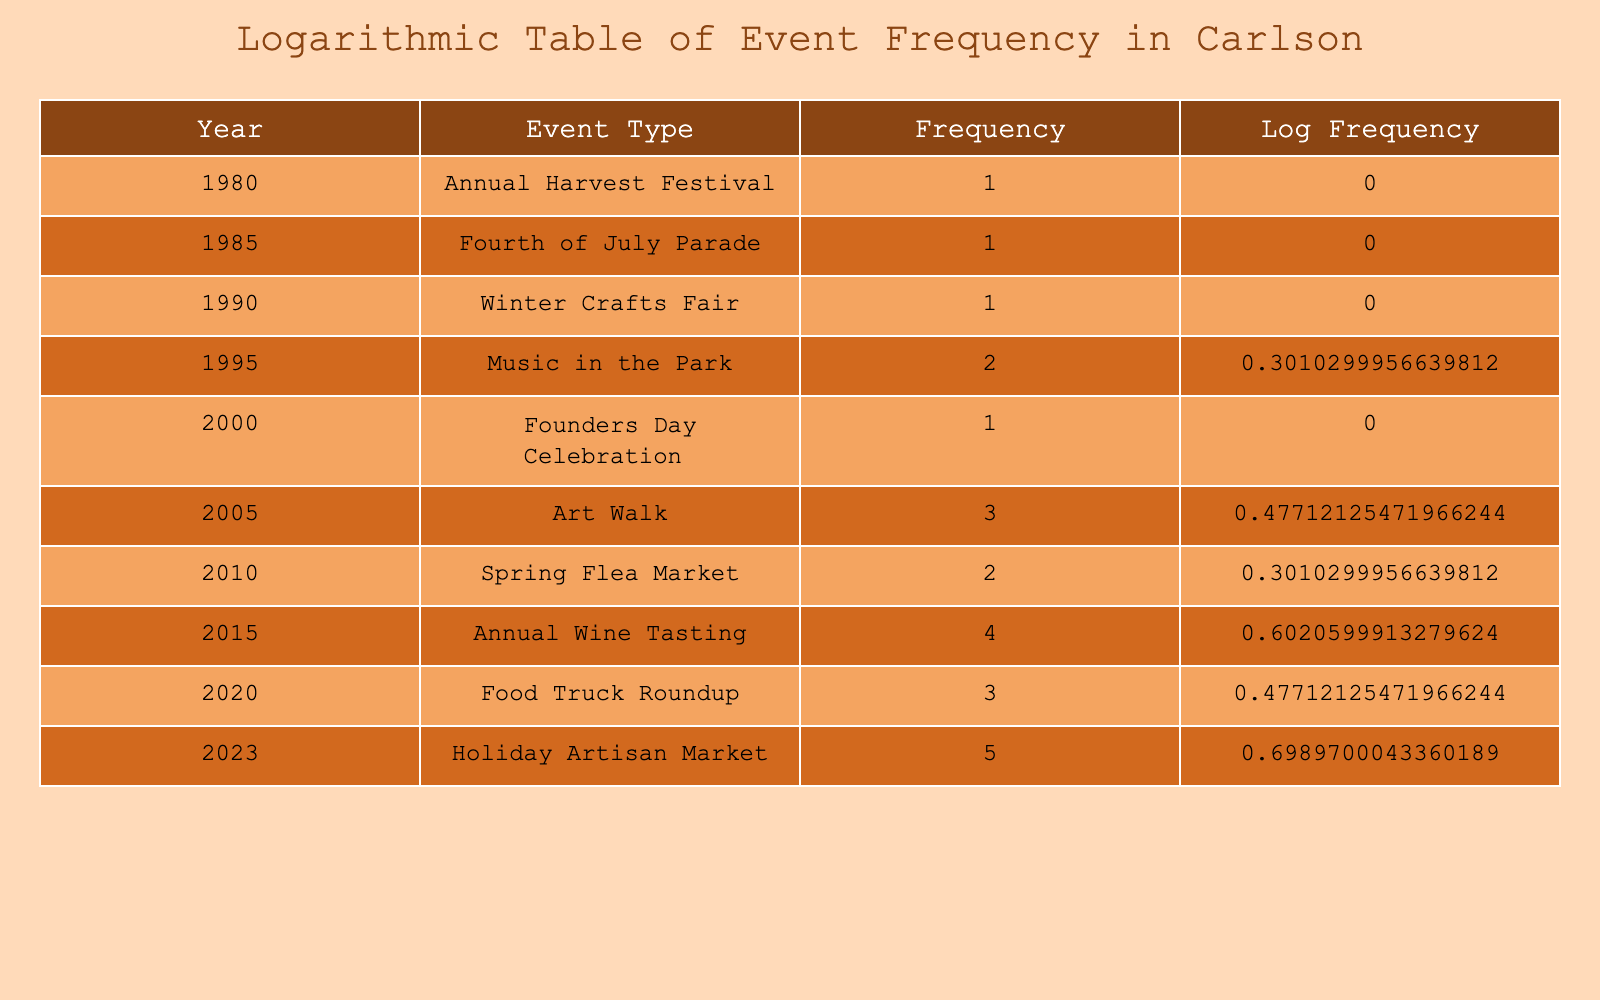What was the frequency of the Annual Harvest Festival? The table shows that the frequency of the Annual Harvest Festival in 1980 is 1.
Answer: 1 How many events had a frequency of 3 or more? Looking at the table, the events with a frequency of 3 are the Art Walk in 2005, the Food Truck Roundup in 2020, and the Holiday Artisan Market in 2023, totaling 3 events.
Answer: 3 What is the average frequency of events from 2010 to 2023? The frequencies from 2010 to 2023 are 2 (Spring Flea Market), 4 (Annual Wine Tasting), 3 (Food Truck Roundup), and 5 (Holiday Artisan Market). Adding these gives 2 + 4 + 3 + 5 = 14. Dividing by the 4 events gives an average of 14/4 = 3.5.
Answer: 3.5 Did the Fourth of July Parade occur more than once? The table states that the Fourth of July Parade had a frequency of 1, meaning it occurred only once.
Answer: No What was the increase in frequency from the Winter Crafts Fair to the Annual Wine Tasting? The frequency of the Winter Crafts Fair in 1990 was 1, while the Annual Wine Tasting in 2015 had a frequency of 4. The increase can be calculated as 4 - 1 = 3.
Answer: 3 Which event had the highest frequency and in what year did it occur? The table shows that the Holiday Artisan Market in 2023 had the highest frequency of 5.
Answer: Holiday Artisan Market, 2023 How many total events were recorded between 1980 and 2023? There are 10 different events listed in the table, counting each row as a distinct event occurring every few years.
Answer: 10 Is it true that the Music in the Park event had a frequency of more than 3? According to the table, the frequency of Music in the Park in 1995 was 2, which means it did not exceed 3.
Answer: No What is the difference in frequency between the Founders Day Celebration and the Holiday Artisan Market? The frequency for Founders Day Celebration in 2000 was 1, while for Holiday Artisan Market in 2023 it was 5. The difference can be calculated as 5 - 1 = 4.
Answer: 4 